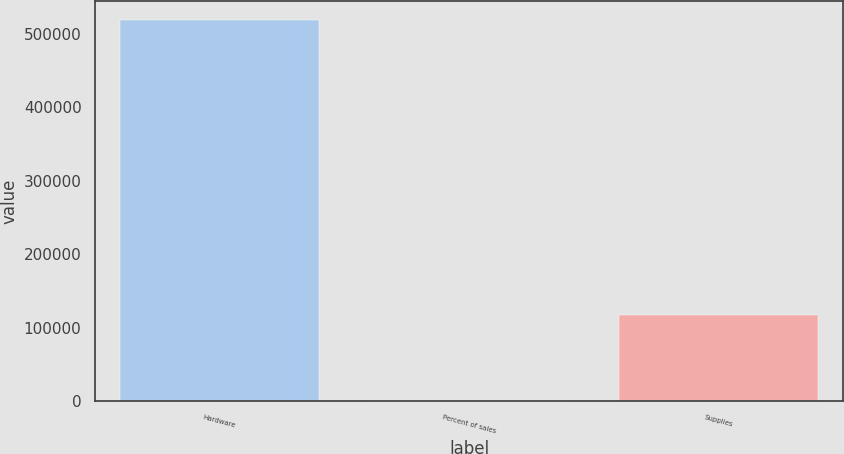Convert chart. <chart><loc_0><loc_0><loc_500><loc_500><bar_chart><fcel>Hardware<fcel>Percent of sales<fcel>Supplies<nl><fcel>518556<fcel>78.2<fcel>116877<nl></chart> 